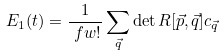Convert formula to latex. <formula><loc_0><loc_0><loc_500><loc_500>E _ { 1 } ( t ) & = \frac { 1 } { \ f w ! } \sum _ { \vec { q } } \det R [ \vec { p } , \vec { q } ] c _ { \vec { q } }</formula> 